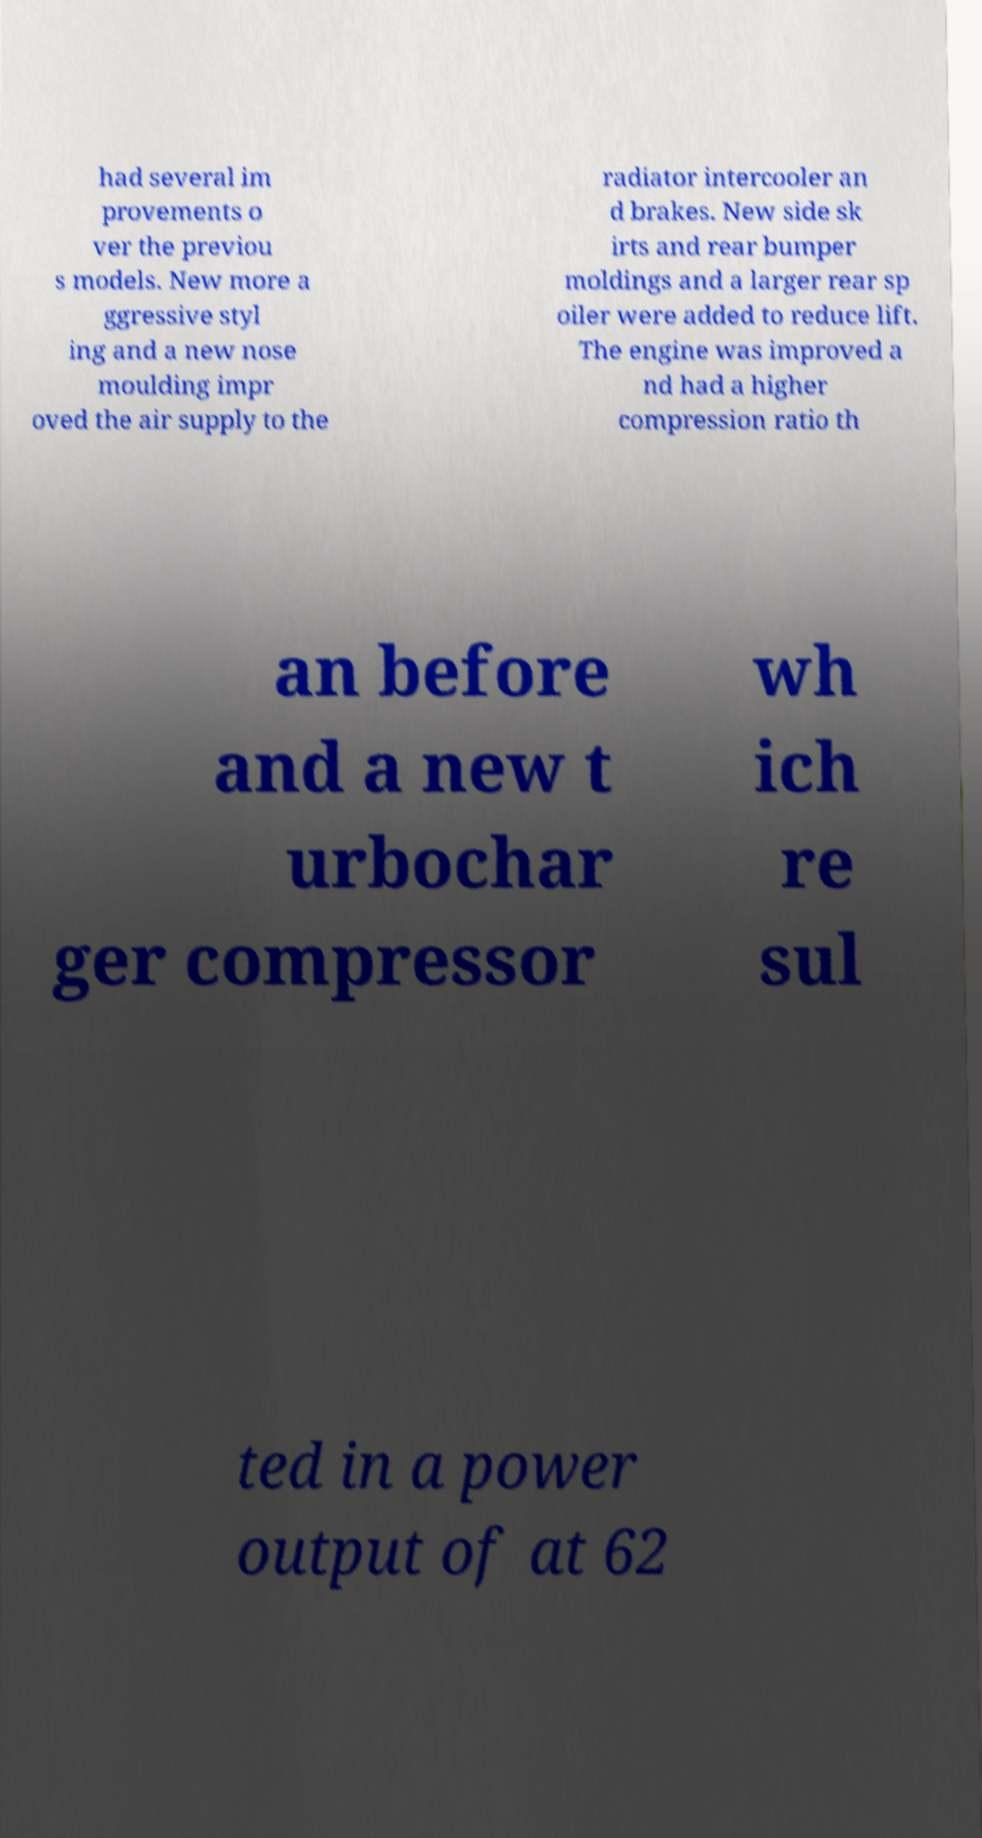For documentation purposes, I need the text within this image transcribed. Could you provide that? had several im provements o ver the previou s models. New more a ggressive styl ing and a new nose moulding impr oved the air supply to the radiator intercooler an d brakes. New side sk irts and rear bumper moldings and a larger rear sp oiler were added to reduce lift. The engine was improved a nd had a higher compression ratio th an before and a new t urbochar ger compressor wh ich re sul ted in a power output of at 62 